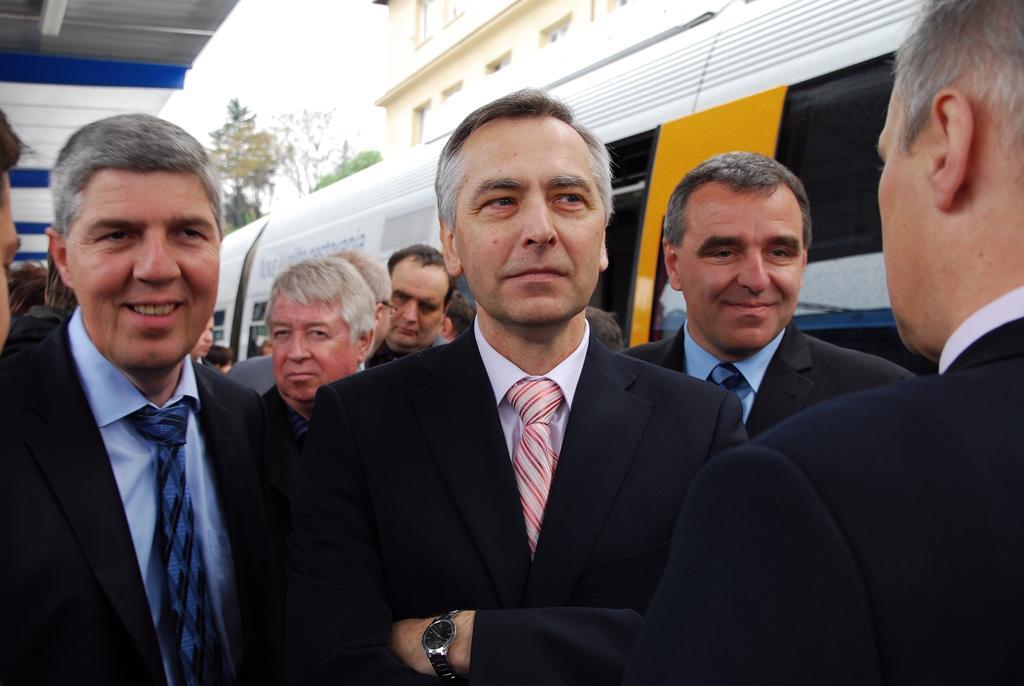How would you summarize this image in a sentence or two? In this picture I can see there are few people standing here and they are wearing blazers and shirts. Onto right side there is a train and it is in white and yellow color. In the backdrop there is a building and trees into right and the sky is clear. 